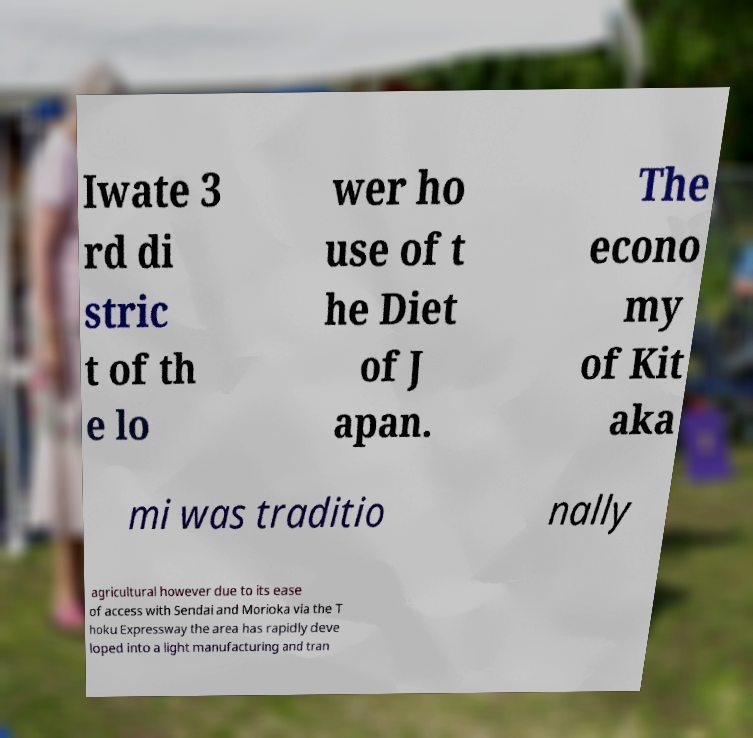Could you assist in decoding the text presented in this image and type it out clearly? Iwate 3 rd di stric t of th e lo wer ho use of t he Diet of J apan. The econo my of Kit aka mi was traditio nally agricultural however due to its ease of access with Sendai and Morioka via the T hoku Expressway the area has rapidly deve loped into a light manufacturing and tran 